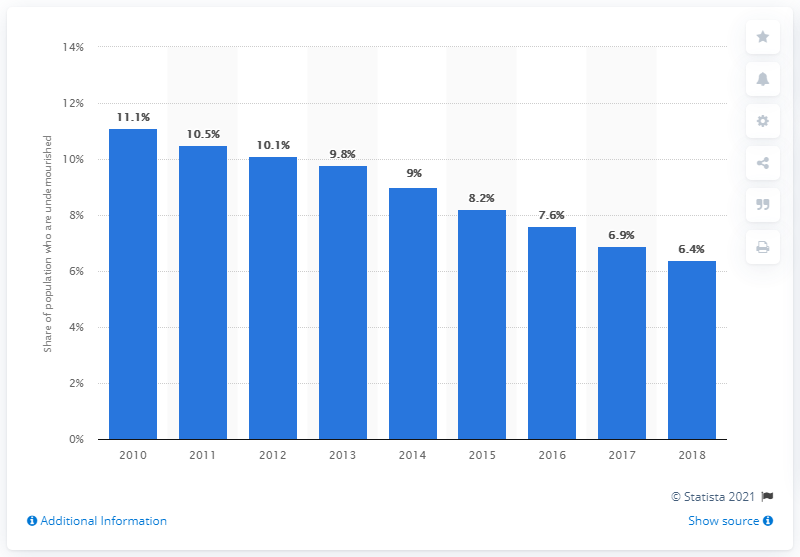Indicate a few pertinent items in this graphic. The value in 2015 is greater than 2018. According to the latest data, the highest percentage of the population who are undernourished is 11.1%. 